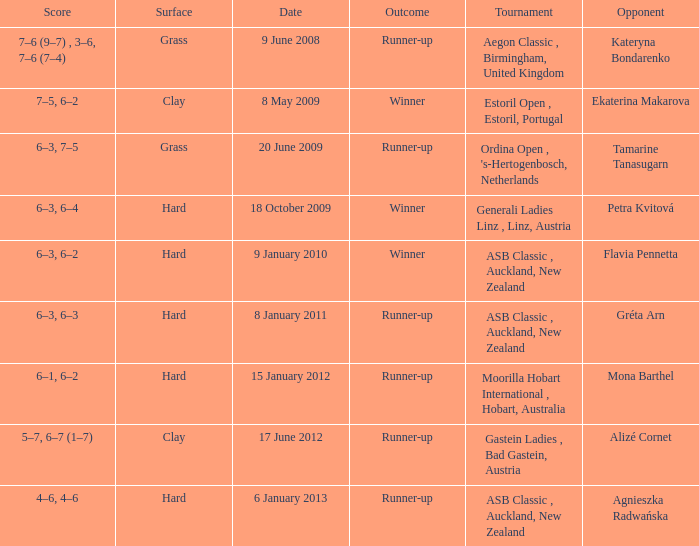What was the result of the match against ekaterina makarova in the tournament? 7–5, 6–2. 